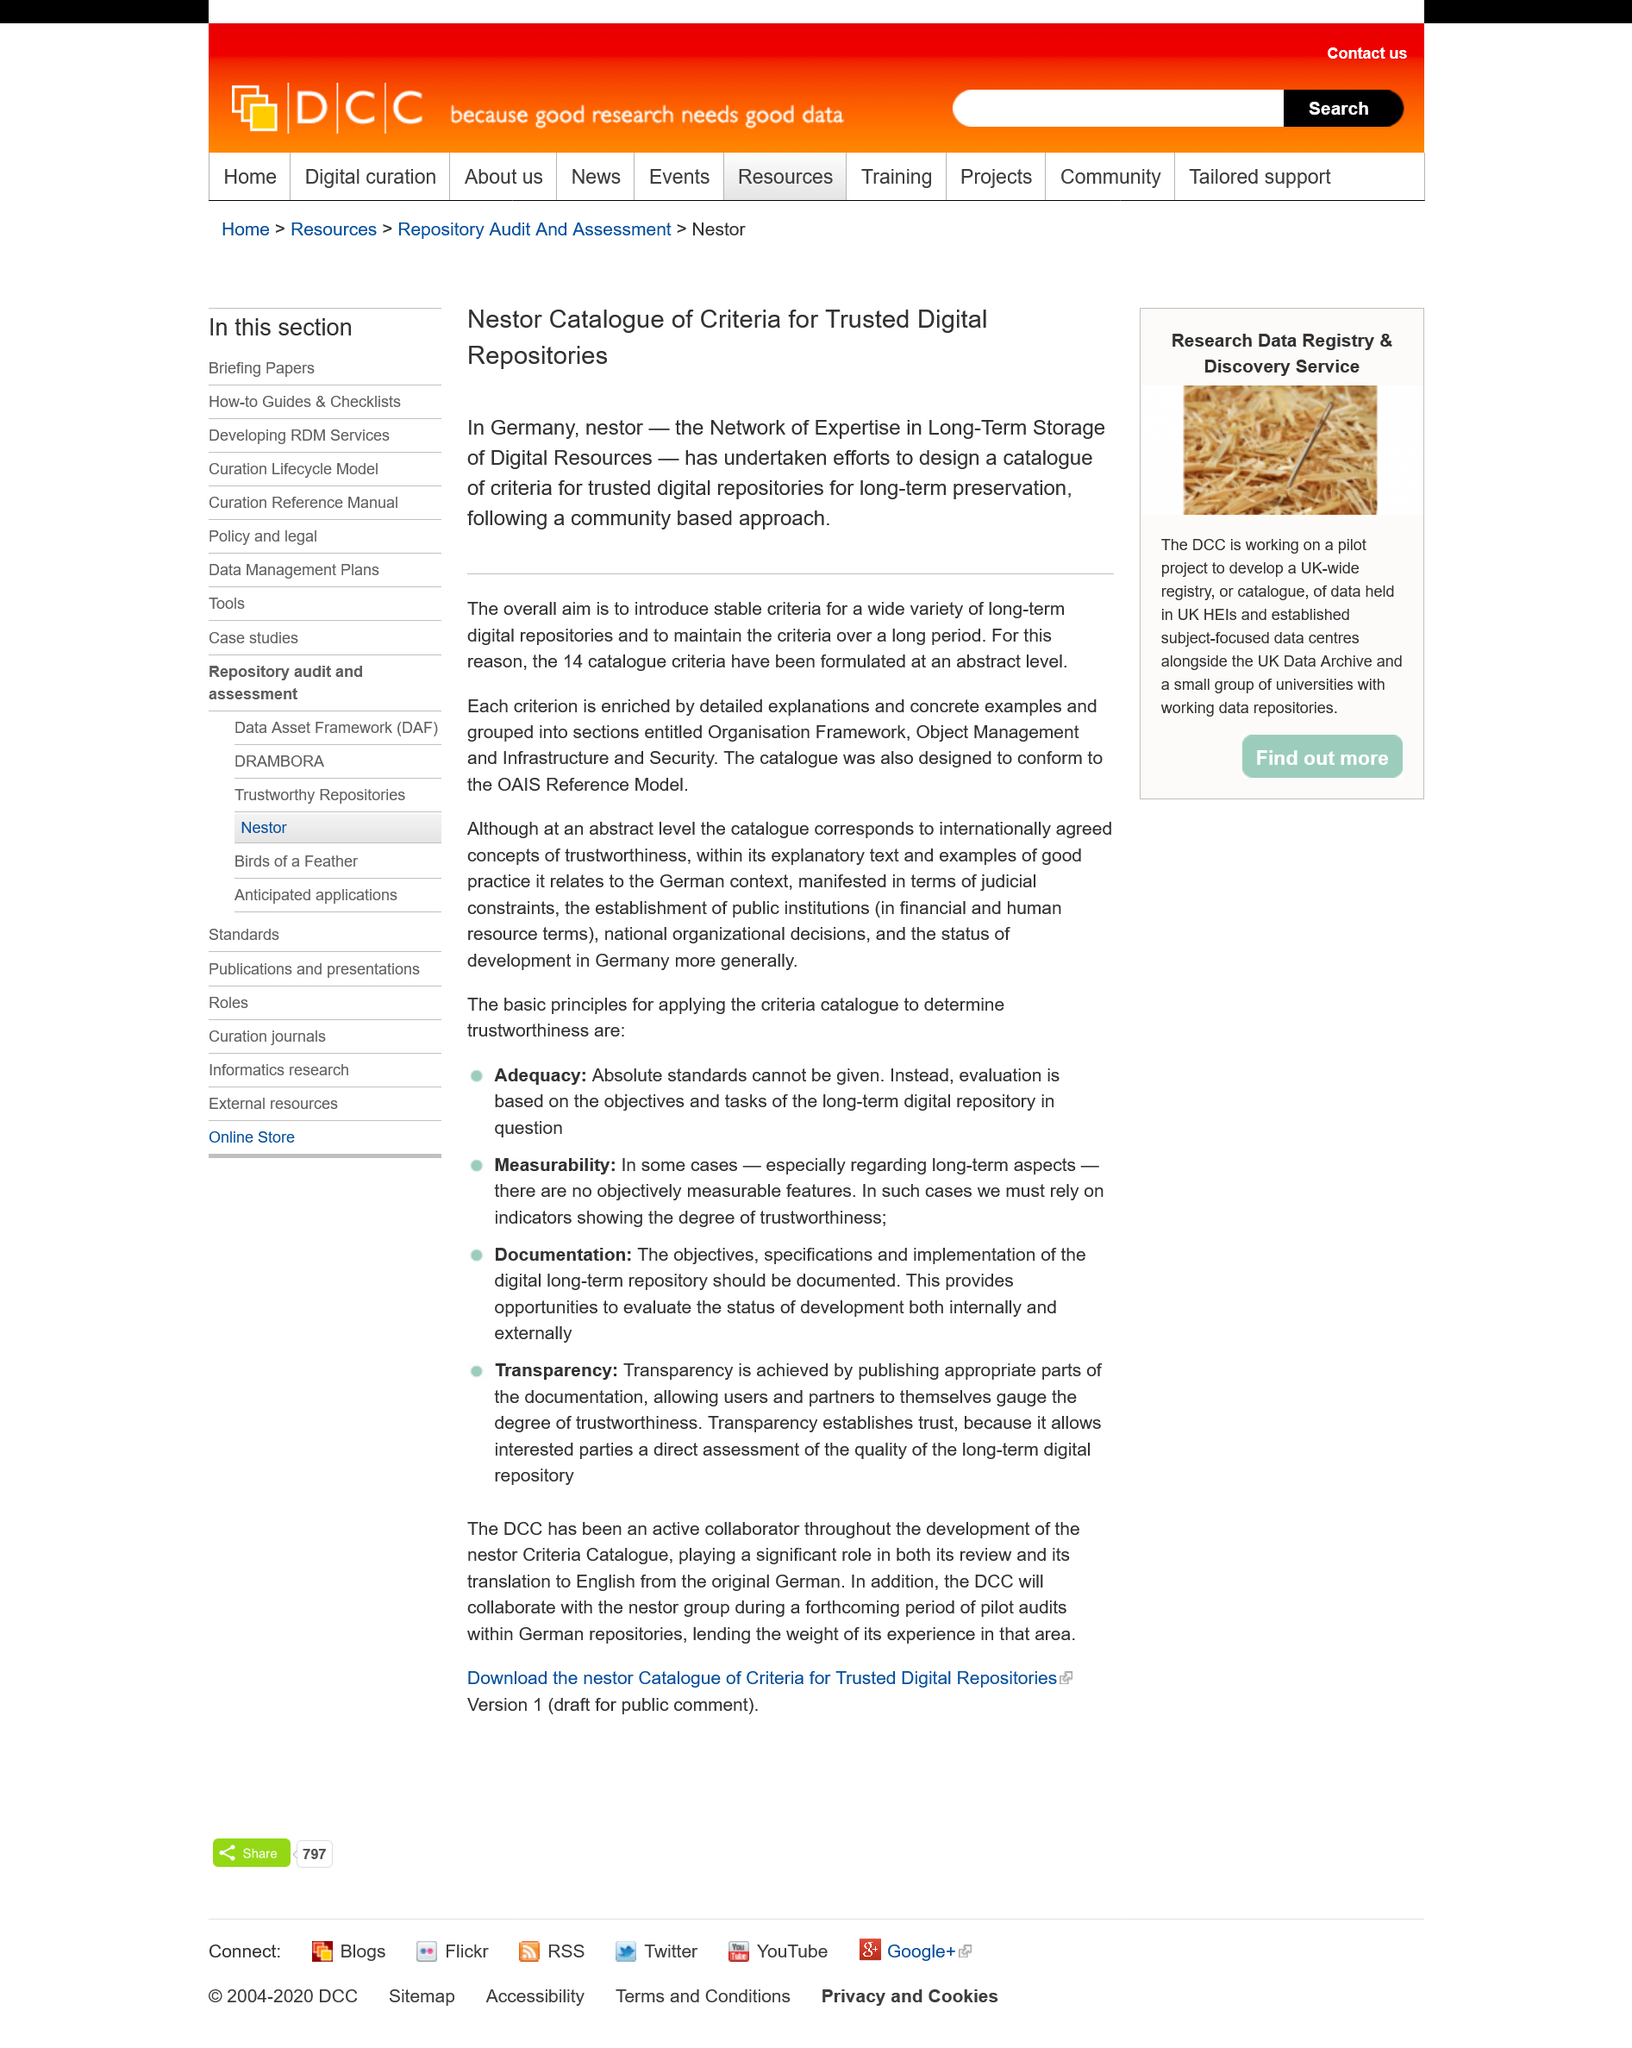Give some essential details in this illustration. The overall aim of NESTOR is to establish consistent and sustainable criteria for a diverse range of long-term digital repositories. A community-based approach is followed in the project. To date, a total of 14 catalogue criteria have been formulated for evaluating the effectiveness of disaster management policies. 